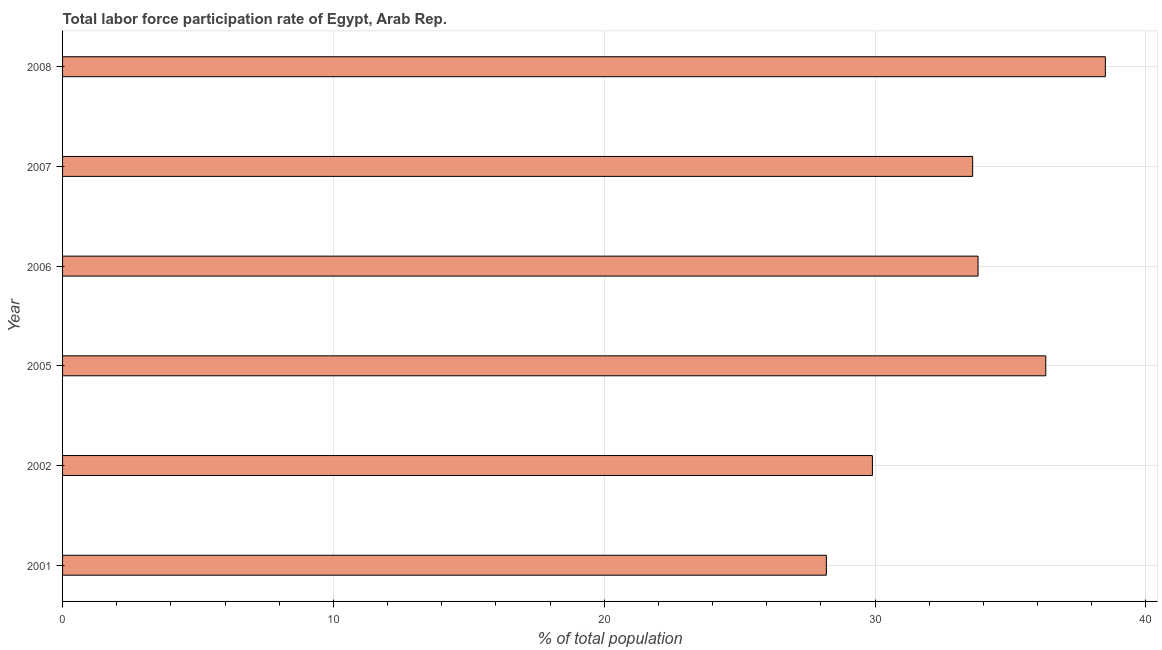What is the title of the graph?
Ensure brevity in your answer.  Total labor force participation rate of Egypt, Arab Rep. What is the label or title of the X-axis?
Ensure brevity in your answer.  % of total population. What is the total labor force participation rate in 2002?
Offer a terse response. 29.9. Across all years, what is the maximum total labor force participation rate?
Your response must be concise. 38.5. Across all years, what is the minimum total labor force participation rate?
Ensure brevity in your answer.  28.2. In which year was the total labor force participation rate maximum?
Offer a very short reply. 2008. In which year was the total labor force participation rate minimum?
Provide a short and direct response. 2001. What is the sum of the total labor force participation rate?
Ensure brevity in your answer.  200.3. What is the difference between the total labor force participation rate in 2002 and 2008?
Keep it short and to the point. -8.6. What is the average total labor force participation rate per year?
Make the answer very short. 33.38. What is the median total labor force participation rate?
Your answer should be compact. 33.7. What is the ratio of the total labor force participation rate in 2007 to that in 2008?
Your answer should be compact. 0.87. Is the total labor force participation rate in 2007 less than that in 2008?
Offer a very short reply. Yes. Is the difference between the total labor force participation rate in 2007 and 2008 greater than the difference between any two years?
Your answer should be very brief. No. Is the sum of the total labor force participation rate in 2002 and 2007 greater than the maximum total labor force participation rate across all years?
Keep it short and to the point. Yes. How many bars are there?
Provide a succinct answer. 6. What is the difference between two consecutive major ticks on the X-axis?
Your answer should be very brief. 10. What is the % of total population in 2001?
Your answer should be compact. 28.2. What is the % of total population of 2002?
Offer a terse response. 29.9. What is the % of total population of 2005?
Ensure brevity in your answer.  36.3. What is the % of total population in 2006?
Offer a very short reply. 33.8. What is the % of total population of 2007?
Your response must be concise. 33.6. What is the % of total population in 2008?
Offer a very short reply. 38.5. What is the difference between the % of total population in 2001 and 2002?
Give a very brief answer. -1.7. What is the difference between the % of total population in 2001 and 2005?
Provide a succinct answer. -8.1. What is the difference between the % of total population in 2001 and 2006?
Offer a terse response. -5.6. What is the difference between the % of total population in 2001 and 2007?
Ensure brevity in your answer.  -5.4. What is the difference between the % of total population in 2002 and 2006?
Keep it short and to the point. -3.9. What is the difference between the % of total population in 2005 and 2006?
Ensure brevity in your answer.  2.5. What is the difference between the % of total population in 2005 and 2007?
Your response must be concise. 2.7. What is the difference between the % of total population in 2005 and 2008?
Ensure brevity in your answer.  -2.2. What is the difference between the % of total population in 2006 and 2007?
Make the answer very short. 0.2. What is the difference between the % of total population in 2007 and 2008?
Provide a short and direct response. -4.9. What is the ratio of the % of total population in 2001 to that in 2002?
Keep it short and to the point. 0.94. What is the ratio of the % of total population in 2001 to that in 2005?
Make the answer very short. 0.78. What is the ratio of the % of total population in 2001 to that in 2006?
Provide a short and direct response. 0.83. What is the ratio of the % of total population in 2001 to that in 2007?
Give a very brief answer. 0.84. What is the ratio of the % of total population in 2001 to that in 2008?
Your answer should be compact. 0.73. What is the ratio of the % of total population in 2002 to that in 2005?
Keep it short and to the point. 0.82. What is the ratio of the % of total population in 2002 to that in 2006?
Offer a terse response. 0.89. What is the ratio of the % of total population in 2002 to that in 2007?
Keep it short and to the point. 0.89. What is the ratio of the % of total population in 2002 to that in 2008?
Provide a succinct answer. 0.78. What is the ratio of the % of total population in 2005 to that in 2006?
Your answer should be very brief. 1.07. What is the ratio of the % of total population in 2005 to that in 2007?
Your response must be concise. 1.08. What is the ratio of the % of total population in 2005 to that in 2008?
Your answer should be compact. 0.94. What is the ratio of the % of total population in 2006 to that in 2007?
Your response must be concise. 1.01. What is the ratio of the % of total population in 2006 to that in 2008?
Ensure brevity in your answer.  0.88. What is the ratio of the % of total population in 2007 to that in 2008?
Provide a succinct answer. 0.87. 